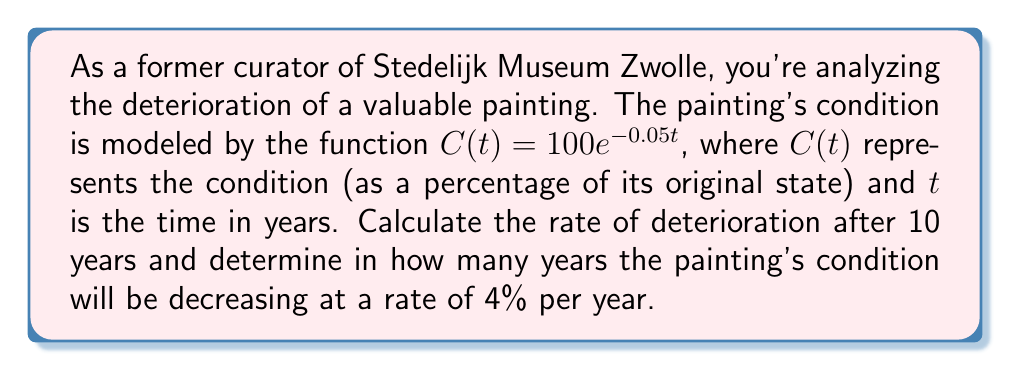Solve this math problem. 1. To find the rate of deterioration, we need to calculate the derivative of $C(t)$:
   $$C'(t) = 100 \cdot (-0.05)e^{-0.05t} = -5e^{-0.05t}$$

2. The rate of deterioration after 10 years:
   $$C'(10) = -5e^{-0.05(10)} = -5e^{-0.5} \approx -3.03$$
   This means the painting is deteriorating at a rate of about 3.03% per year after 10 years.

3. To find when the rate of deterioration is 4% per year, we set up the equation:
   $$-5e^{-0.05t} = -4$$

4. Solve for $t$:
   $$e^{-0.05t} = \frac{4}{5}$$
   $$-0.05t = \ln(\frac{4}{5})$$
   $$t = -\frac{\ln(\frac{4}{5})}{0.05} \approx 4.46$$

Therefore, the painting's condition will be decreasing at a rate of 4% per year after approximately 4.46 years.
Answer: 3.03% per year after 10 years; 4.46 years for 4% annual deterioration rate 